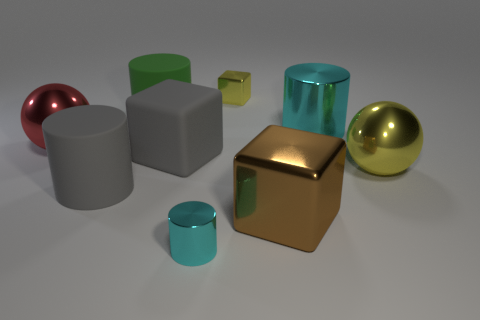Do the big brown metallic thing and the small yellow thing have the same shape?
Provide a short and direct response. Yes. How big is the cyan shiny object that is in front of the large block that is to the right of the yellow thing left of the yellow metal ball?
Offer a very short reply. Small. What is the material of the large gray block?
Give a very brief answer. Rubber. There is a metallic object that is the same color as the small cylinder; what size is it?
Your answer should be compact. Large. Does the large green rubber object have the same shape as the cyan metallic object to the right of the tiny cyan metal object?
Offer a very short reply. Yes. What is the material of the big gray thing that is in front of the big gray object behind the large metal ball that is to the right of the tiny yellow metal object?
Offer a very short reply. Rubber. What number of tiny cyan metallic things are there?
Your answer should be compact. 1. What number of cyan things are either big rubber cylinders or metallic objects?
Make the answer very short. 2. What number of other objects are there of the same shape as the big cyan shiny object?
Keep it short and to the point. 3. Does the large block that is behind the yellow metallic sphere have the same color as the matte cylinder in front of the red thing?
Your answer should be compact. Yes. 